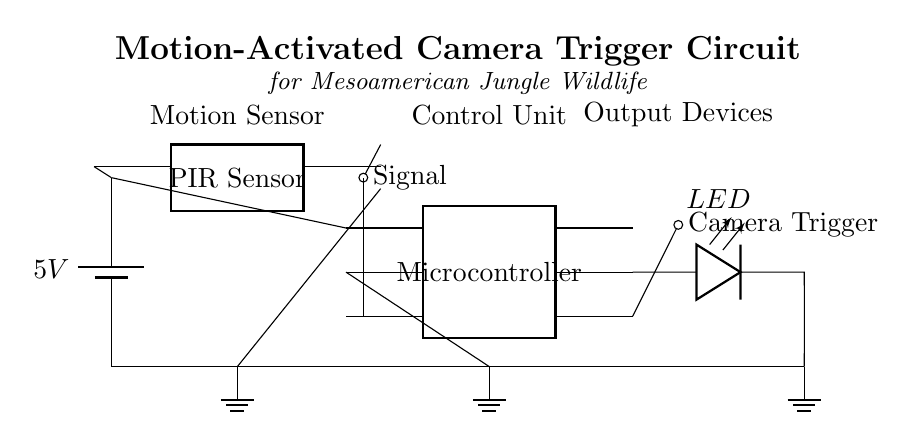What is the power supply voltage? The voltage provides the necessary energy to operate the circuit components. It is specified as 5V at the battery, which serves as the power supply.
Answer: 5V What type of sensor is used in this circuit? The circuit diagram shows a PIR sensor, commonly used for detecting motion based on changes in infrared radiation, typically emitted by moving objects like animals.
Answer: PIR Sensor Which component activates the camera trigger? The camera trigger is activated by the output signal from the microcontroller when it detects motion from the PIR sensor. The circuit shows a direct connection from the microcontroller to the camera trigger.
Answer: Microcontroller What does the LED indicate in this circuit? The LED is connected to the microcontroller and serves as an indicator light, showing the operational state of the circuit, such as whether it is active or has detected motion.
Answer: LED How many pins does the microcontroller contain? The microcontroller is shown to have six pins in the diagram, which indicates its capability to connect with multiple components.
Answer: Six pins What is the function of the PIR sensor in this circuit? The PIR sensor detects motion by sensing infrared radiation changes, sending a signal to the microcontroller to trigger the camera. Its role is crucial as it initiates the operation of the trigger when motion is detected.
Answer: Detection of motion Which direction does the signal from the PIR sensor go? The signal from the PIR sensor travels downwards to the microcontroller and is then processed to trigger the camera, indicating a flow of information from the sensor to the control unit.
Answer: Downwards 